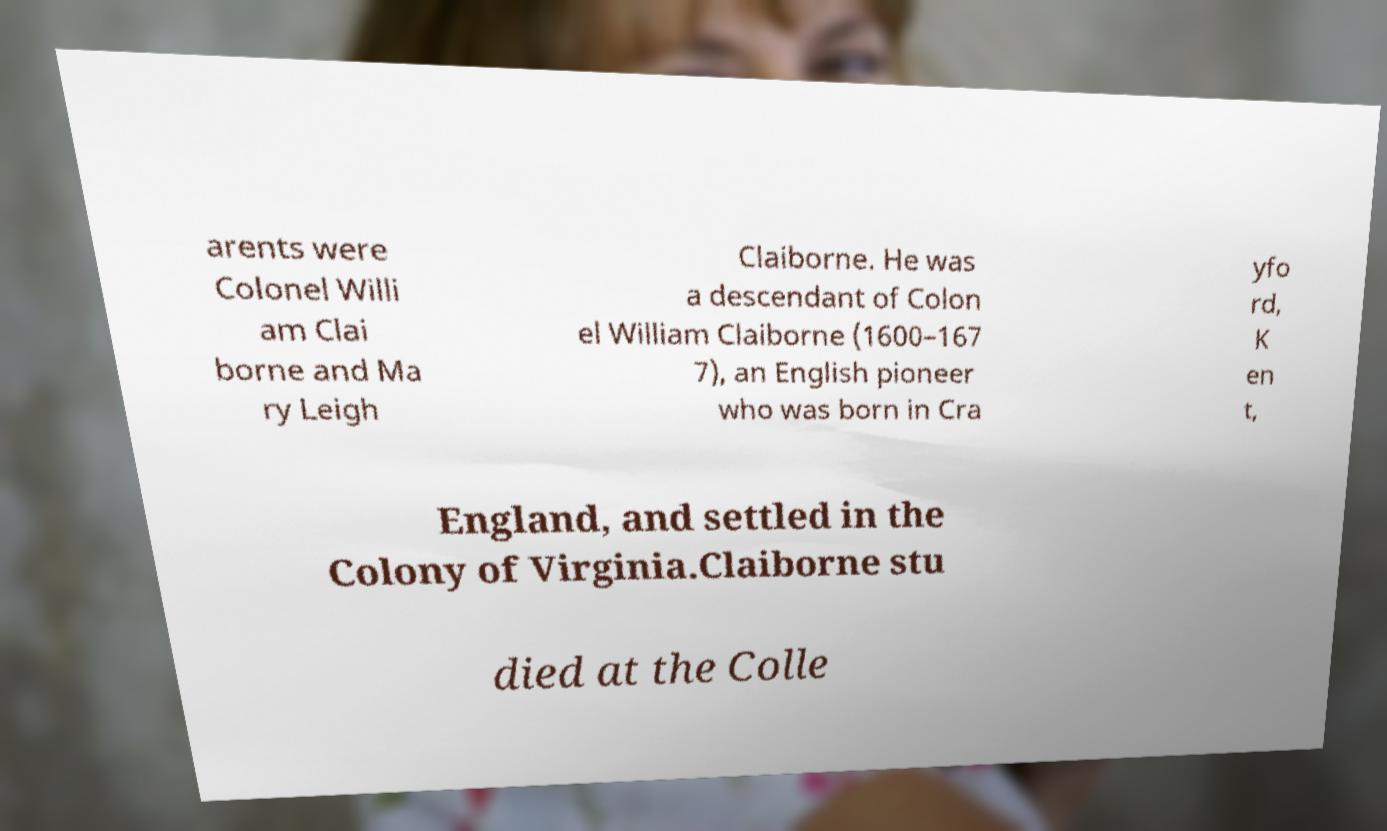Can you read and provide the text displayed in the image?This photo seems to have some interesting text. Can you extract and type it out for me? arents were Colonel Willi am Clai borne and Ma ry Leigh Claiborne. He was a descendant of Colon el William Claiborne (1600–167 7), an English pioneer who was born in Cra yfo rd, K en t, England, and settled in the Colony of Virginia.Claiborne stu died at the Colle 